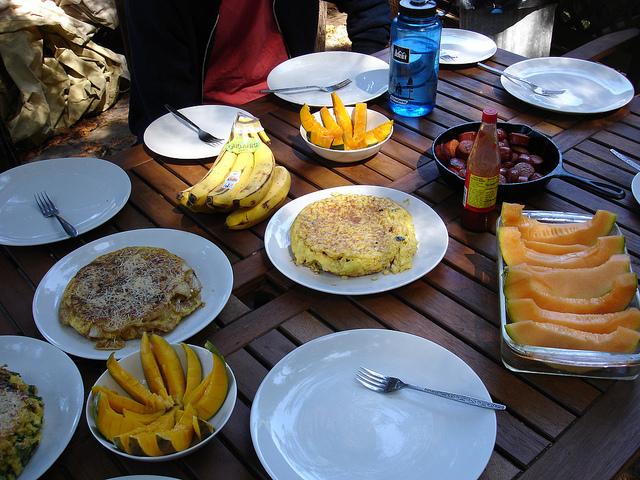Where is the cantaloupe?
Be succinct. On table. How many people are eating?
Write a very short answer. 6. How many plates are set at this table?
Short answer required. 7. 